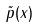<formula> <loc_0><loc_0><loc_500><loc_500>\tilde { p } ( x )</formula> 